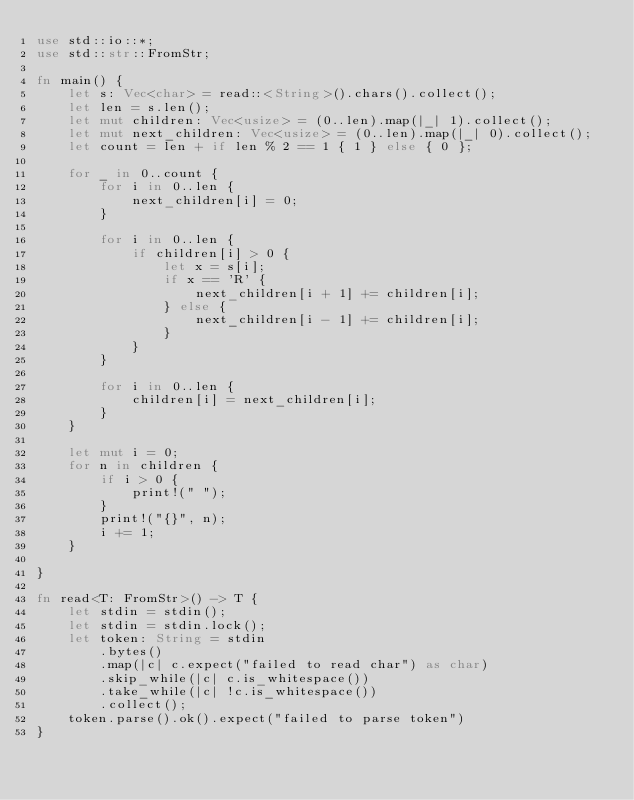<code> <loc_0><loc_0><loc_500><loc_500><_Rust_>use std::io::*;
use std::str::FromStr;

fn main() {
    let s: Vec<char> = read::<String>().chars().collect();
    let len = s.len();
    let mut children: Vec<usize> = (0..len).map(|_| 1).collect();
    let mut next_children: Vec<usize> = (0..len).map(|_| 0).collect();
    let count = len + if len % 2 == 1 { 1 } else { 0 };

    for _ in 0..count {
        for i in 0..len {
            next_children[i] = 0;
        }

        for i in 0..len {
            if children[i] > 0 {
                let x = s[i];
                if x == 'R' {
                    next_children[i + 1] += children[i];
                } else {
                    next_children[i - 1] += children[i];
                }
            }
        }
        
        for i in 0..len {
            children[i] = next_children[i];
        }
    }

    let mut i = 0;
    for n in children {
        if i > 0 {
            print!(" ");
        }
        print!("{}", n);
        i += 1;
    }

}

fn read<T: FromStr>() -> T {
    let stdin = stdin();
    let stdin = stdin.lock();
    let token: String = stdin
        .bytes()
        .map(|c| c.expect("failed to read char") as char)
        .skip_while(|c| c.is_whitespace())
        .take_while(|c| !c.is_whitespace())
        .collect();
    token.parse().ok().expect("failed to parse token")
}
</code> 